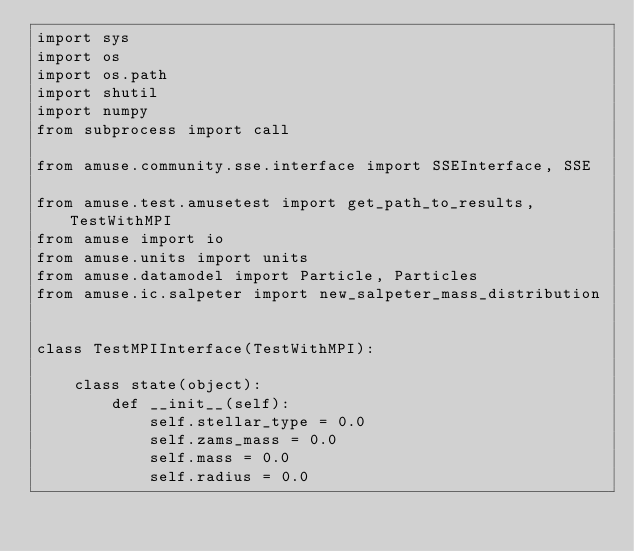<code> <loc_0><loc_0><loc_500><loc_500><_Python_>import sys
import os
import os.path
import shutil
import numpy
from subprocess import call

from amuse.community.sse.interface import SSEInterface, SSE

from amuse.test.amusetest import get_path_to_results, TestWithMPI
from amuse import io
from amuse.units import units
from amuse.datamodel import Particle, Particles
from amuse.ic.salpeter import new_salpeter_mass_distribution


class TestMPIInterface(TestWithMPI):
    
    class state(object):
        def __init__(self):
            self.stellar_type = 0.0
            self.zams_mass = 0.0
            self.mass = 0.0
            self.radius = 0.0</code> 